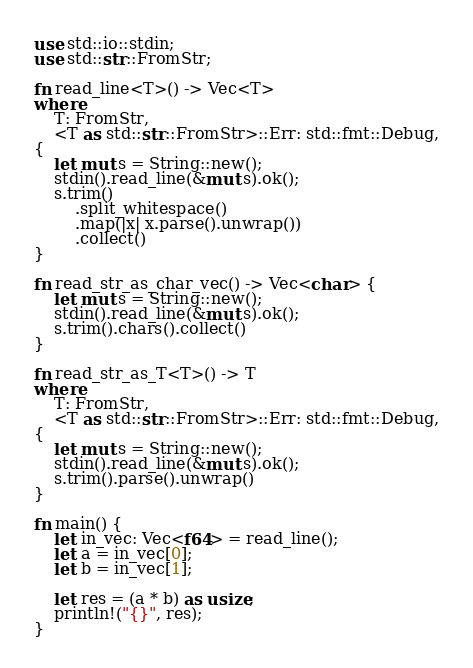Convert code to text. <code><loc_0><loc_0><loc_500><loc_500><_Rust_>use std::io::stdin;
use std::str::FromStr;

fn read_line<T>() -> Vec<T>
where
    T: FromStr,
    <T as std::str::FromStr>::Err: std::fmt::Debug,
{
    let mut s = String::new();
    stdin().read_line(&mut s).ok();
    s.trim()
        .split_whitespace()
        .map(|x| x.parse().unwrap())
        .collect()
}

fn read_str_as_char_vec() -> Vec<char> {
    let mut s = String::new();
    stdin().read_line(&mut s).ok();
    s.trim().chars().collect()
}

fn read_str_as_T<T>() -> T
where
    T: FromStr,
    <T as std::str::FromStr>::Err: std::fmt::Debug,
{
    let mut s = String::new();
    stdin().read_line(&mut s).ok();
    s.trim().parse().unwrap()
}

fn main() {
    let in_vec: Vec<f64> = read_line();
    let a = in_vec[0];
    let b = in_vec[1];

    let res = (a * b) as usize;
    println!("{}", res);
}
</code> 